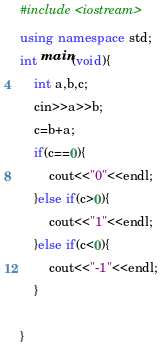<code> <loc_0><loc_0><loc_500><loc_500><_C++_>#include <iostream>
using namespace std;
int main(void){
    int a,b,c;
    cin>>a>>b;
    c=b+a;
    if(c==0){
        cout<<"0"<<endl;
    }else if(c>0){
        cout<<"1"<<endl;
    }else if(c<0){
        cout<<"-1"<<endl;
    }
    
}

</code> 